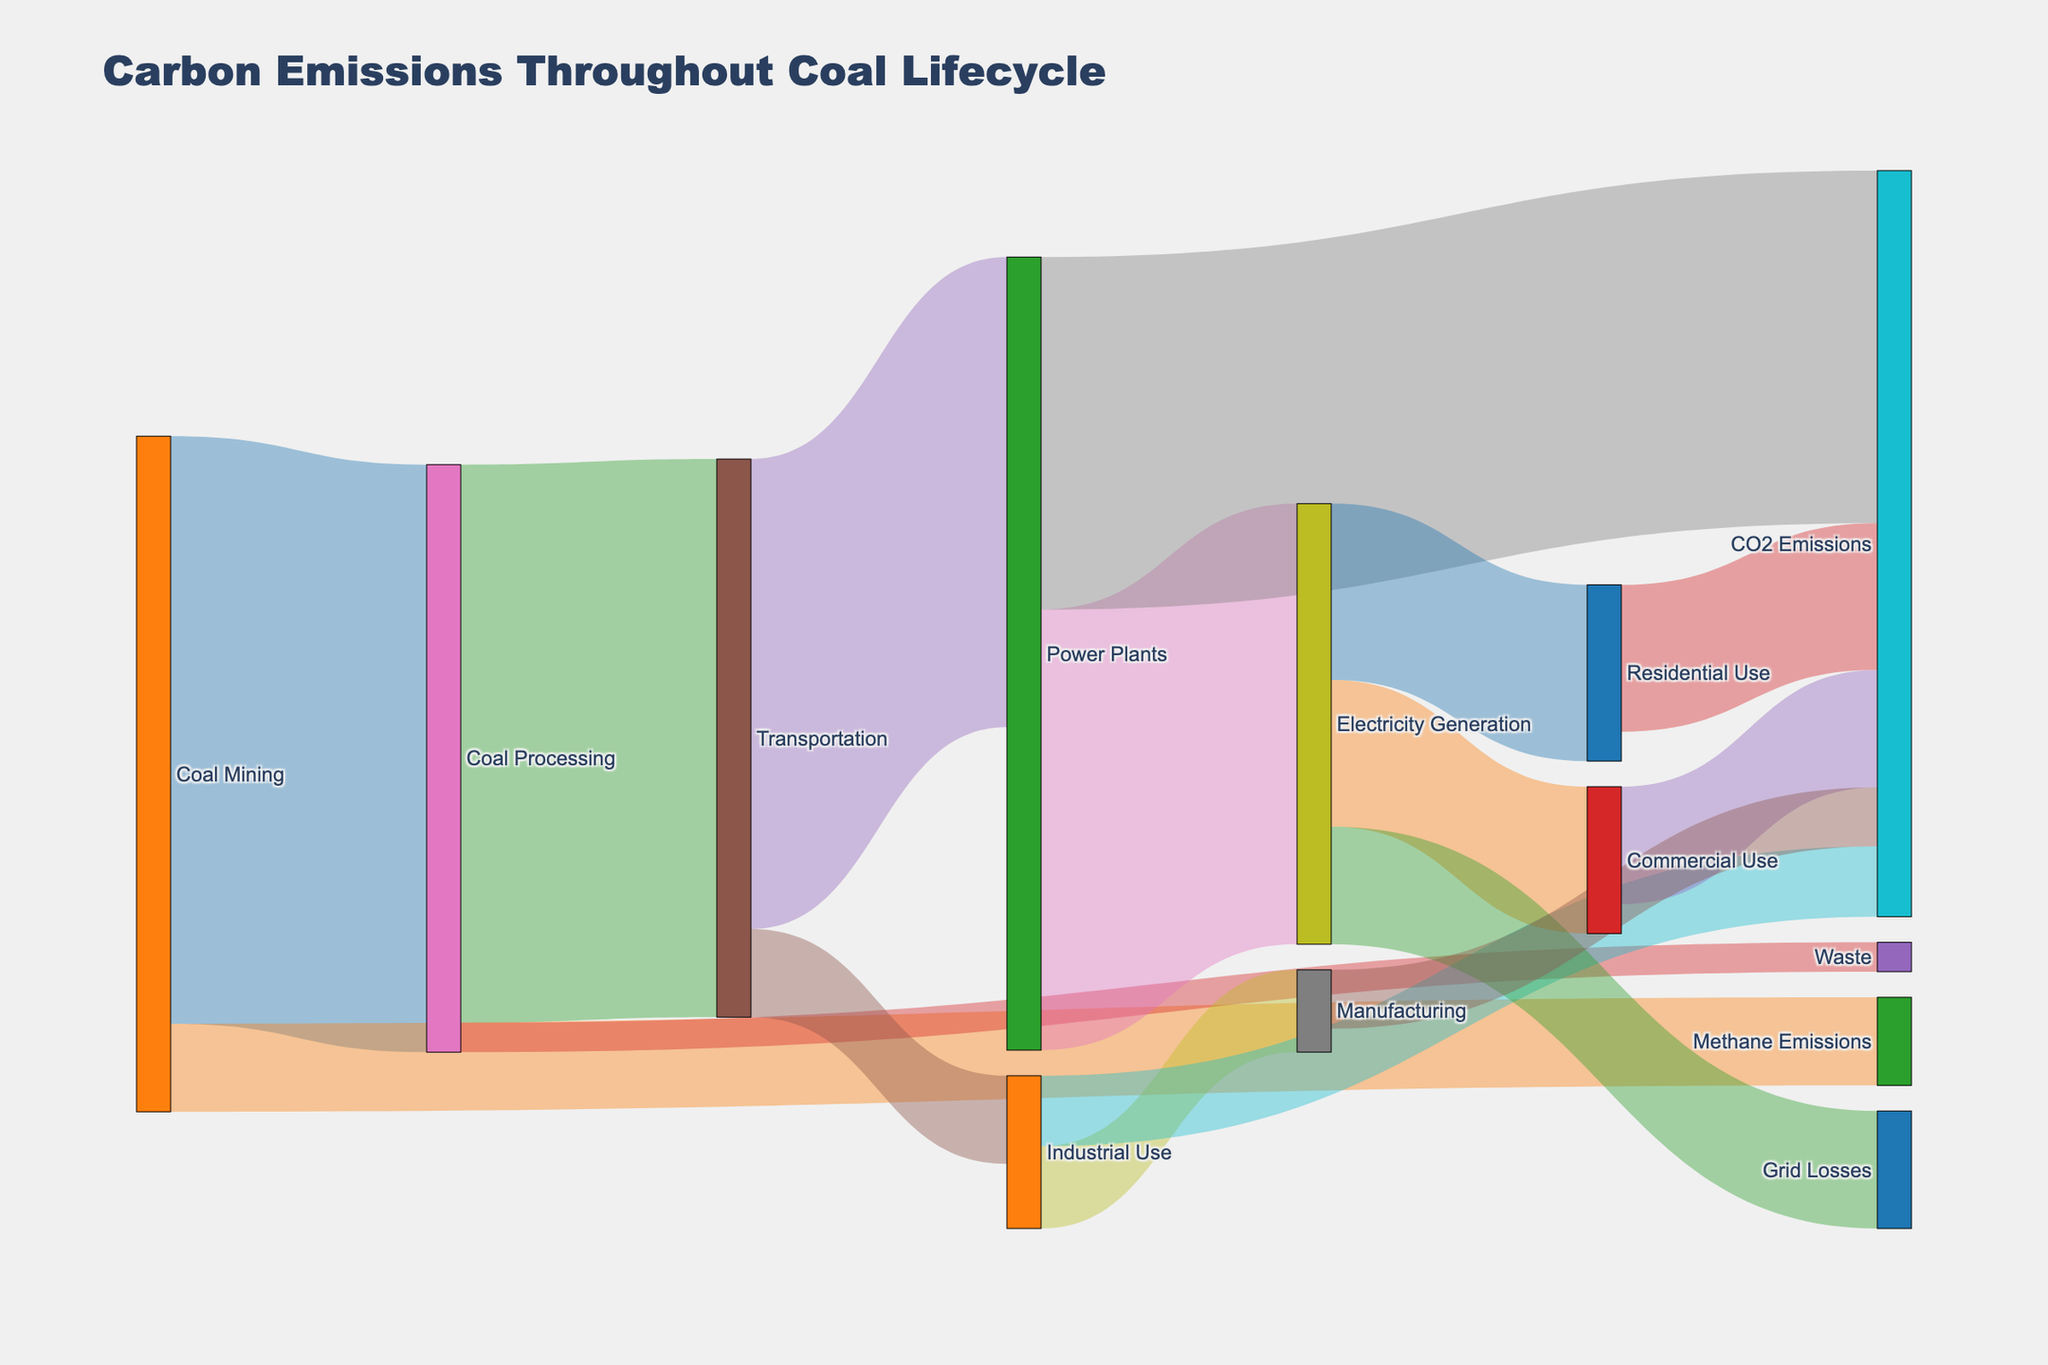What are the primary sources of CO2 emissions in the coal lifecycle? The Sankey diagram shows four paths leading to "CO2 Emissions" from "Power Plants," "Industrial Use," "Residential Use," and "Commercial Use." Following these paths indicates that these are the primary sources.
Answer: Power Plants, Industrial Use, Residential Use, Commercial Use How much coal is transported to power plants? The flow from "Transportation" to "Power Plants" is labeled with a value of 80, indicating the amount of coal transported to power plants.
Answer: 80 What's the total amount of CO2 emissions from the power plants? The value from "Power Plants" to "CO2 Emissions" is 60, indicating the total emissions from power plants.
Answer: 60 How many pathways lead to "Electricity Generation"? Tracing the flows leading to "Electricity Generation" shows one pathway from "Power Plants".
Answer: 1 Can you identify the end-use sectors consuming the electricity generated from coal? The Sankey diagram shows "Electricity Generation" branching into "Residential Use," "Commercial Use," and "Grid Losses." These are the end-use sectors.
Answer: Residential Use, Commercial Use, Grid Losses Which process generates the highest amount of waste in the coal lifecycle? The flow from "Coal Processing" to "Waste" is 5. By checking all paths with "Waste," we see this is the highest.
Answer: Coal Processing What is the difference in CO2 emissions between Residential and Commercial use of electricity? The flow from "Residential Use" to "CO2 Emissions" is 25, and the flow from "Commercial Use" to "CO2 Emissions" is 20. Subtracting these (25 - 20) gives 5.
Answer: 5 What percentage of coal mined goes to methane emissions directly? The amount from "Coal Mining" to "Methane Emissions" is 15 out of a total mined of 115 (100 to processing + 15 to methane). Therefore, (15/115)*100 is approximately 13.04%.
Answer: 13.04% Compare the amount of coal used in industrial applications to that in power plants. Which is higher? The flow from "Transportation" to "Power Plants" is 80, and to "Industrial Use" is 15. Thus, more coal is used in power plants compared to industrial applications.
Answer: Power Plants What is the total amount of emissions (CO2 and Methane) in the coal lifecycle? Adding the values for all CO2 and Methane emissions: Methane (15) and CO2 (60 + 12 + 25 + 20 + 10), the total is 15 + 127 = 142.
Answer: 142 